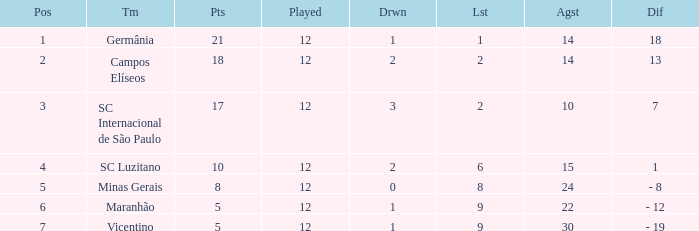What difference has a points greater than 10, and a drawn less than 2? 18.0. 